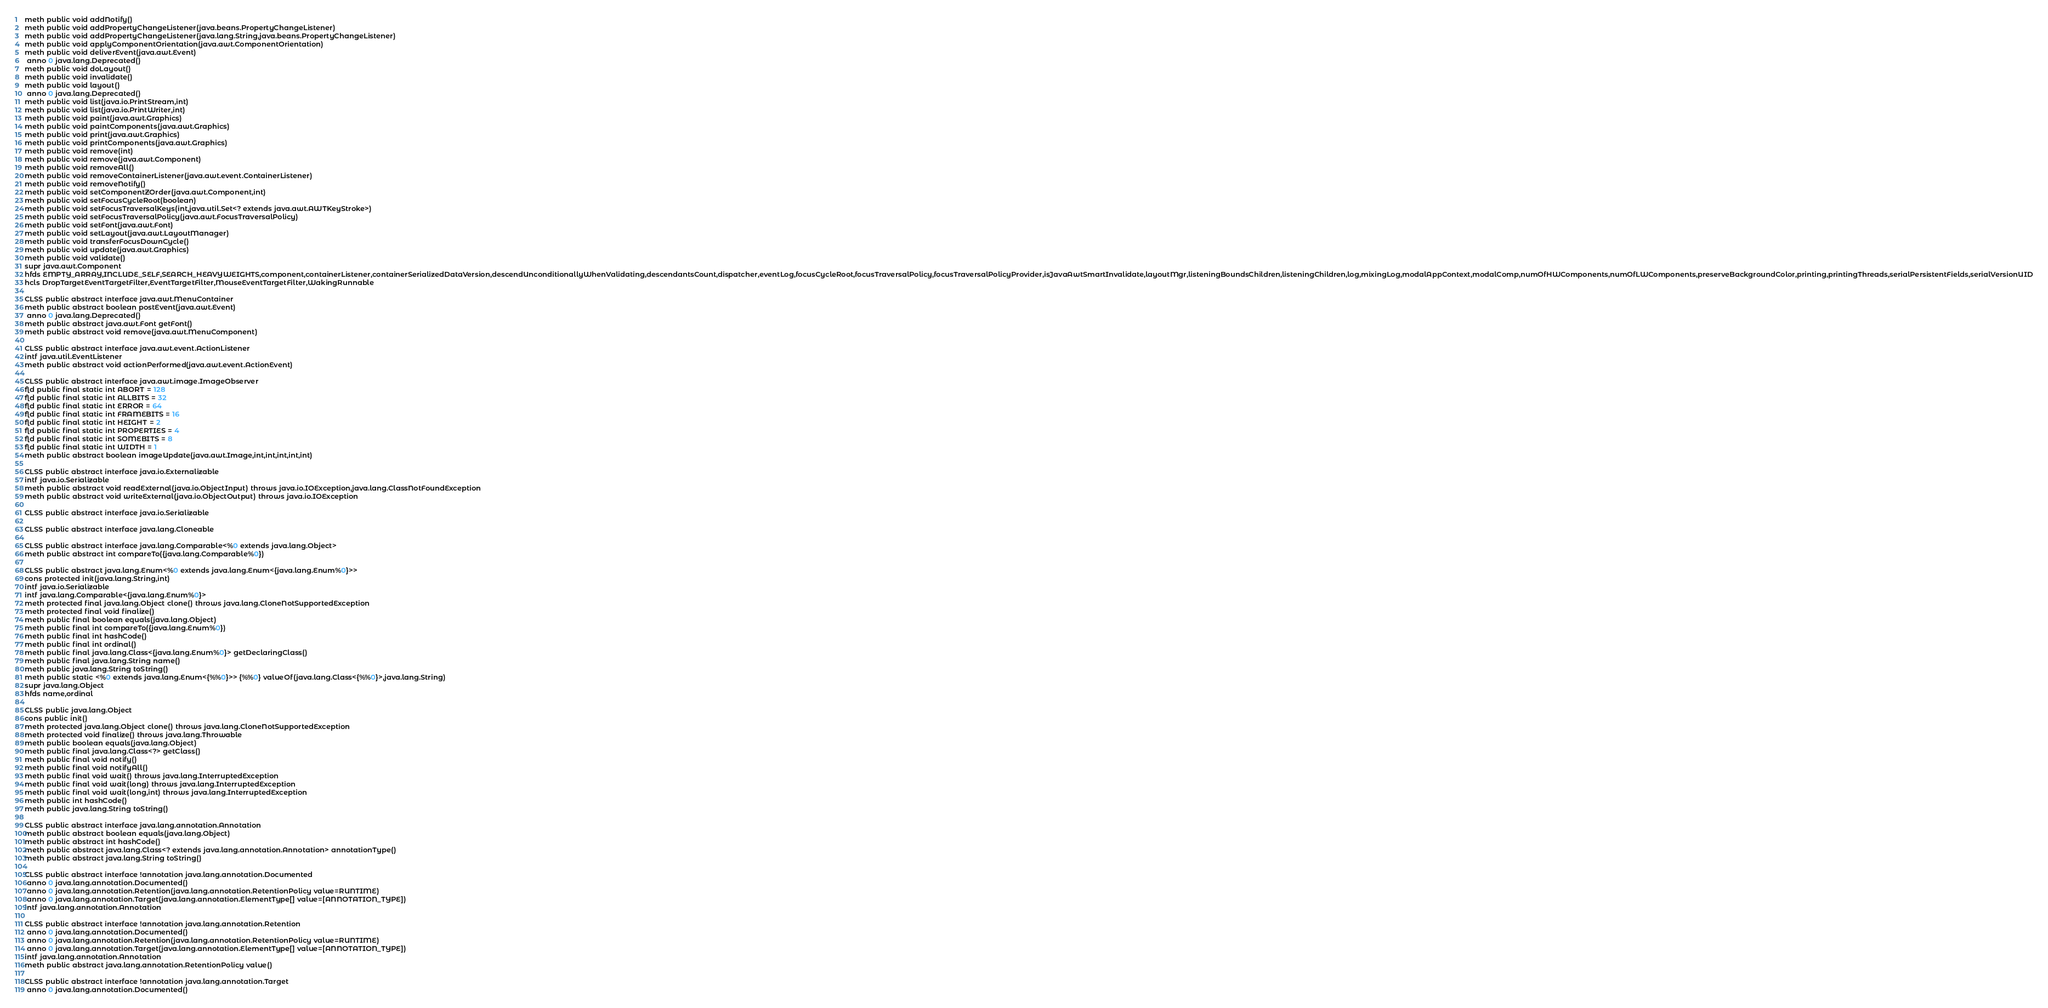Convert code to text. <code><loc_0><loc_0><loc_500><loc_500><_SML_>meth public void addNotify()
meth public void addPropertyChangeListener(java.beans.PropertyChangeListener)
meth public void addPropertyChangeListener(java.lang.String,java.beans.PropertyChangeListener)
meth public void applyComponentOrientation(java.awt.ComponentOrientation)
meth public void deliverEvent(java.awt.Event)
 anno 0 java.lang.Deprecated()
meth public void doLayout()
meth public void invalidate()
meth public void layout()
 anno 0 java.lang.Deprecated()
meth public void list(java.io.PrintStream,int)
meth public void list(java.io.PrintWriter,int)
meth public void paint(java.awt.Graphics)
meth public void paintComponents(java.awt.Graphics)
meth public void print(java.awt.Graphics)
meth public void printComponents(java.awt.Graphics)
meth public void remove(int)
meth public void remove(java.awt.Component)
meth public void removeAll()
meth public void removeContainerListener(java.awt.event.ContainerListener)
meth public void removeNotify()
meth public void setComponentZOrder(java.awt.Component,int)
meth public void setFocusCycleRoot(boolean)
meth public void setFocusTraversalKeys(int,java.util.Set<? extends java.awt.AWTKeyStroke>)
meth public void setFocusTraversalPolicy(java.awt.FocusTraversalPolicy)
meth public void setFont(java.awt.Font)
meth public void setLayout(java.awt.LayoutManager)
meth public void transferFocusDownCycle()
meth public void update(java.awt.Graphics)
meth public void validate()
supr java.awt.Component
hfds EMPTY_ARRAY,INCLUDE_SELF,SEARCH_HEAVYWEIGHTS,component,containerListener,containerSerializedDataVersion,descendUnconditionallyWhenValidating,descendantsCount,dispatcher,eventLog,focusCycleRoot,focusTraversalPolicy,focusTraversalPolicyProvider,isJavaAwtSmartInvalidate,layoutMgr,listeningBoundsChildren,listeningChildren,log,mixingLog,modalAppContext,modalComp,numOfHWComponents,numOfLWComponents,preserveBackgroundColor,printing,printingThreads,serialPersistentFields,serialVersionUID
hcls DropTargetEventTargetFilter,EventTargetFilter,MouseEventTargetFilter,WakingRunnable

CLSS public abstract interface java.awt.MenuContainer
meth public abstract boolean postEvent(java.awt.Event)
 anno 0 java.lang.Deprecated()
meth public abstract java.awt.Font getFont()
meth public abstract void remove(java.awt.MenuComponent)

CLSS public abstract interface java.awt.event.ActionListener
intf java.util.EventListener
meth public abstract void actionPerformed(java.awt.event.ActionEvent)

CLSS public abstract interface java.awt.image.ImageObserver
fld public final static int ABORT = 128
fld public final static int ALLBITS = 32
fld public final static int ERROR = 64
fld public final static int FRAMEBITS = 16
fld public final static int HEIGHT = 2
fld public final static int PROPERTIES = 4
fld public final static int SOMEBITS = 8
fld public final static int WIDTH = 1
meth public abstract boolean imageUpdate(java.awt.Image,int,int,int,int,int)

CLSS public abstract interface java.io.Externalizable
intf java.io.Serializable
meth public abstract void readExternal(java.io.ObjectInput) throws java.io.IOException,java.lang.ClassNotFoundException
meth public abstract void writeExternal(java.io.ObjectOutput) throws java.io.IOException

CLSS public abstract interface java.io.Serializable

CLSS public abstract interface java.lang.Cloneable

CLSS public abstract interface java.lang.Comparable<%0 extends java.lang.Object>
meth public abstract int compareTo({java.lang.Comparable%0})

CLSS public abstract java.lang.Enum<%0 extends java.lang.Enum<{java.lang.Enum%0}>>
cons protected init(java.lang.String,int)
intf java.io.Serializable
intf java.lang.Comparable<{java.lang.Enum%0}>
meth protected final java.lang.Object clone() throws java.lang.CloneNotSupportedException
meth protected final void finalize()
meth public final boolean equals(java.lang.Object)
meth public final int compareTo({java.lang.Enum%0})
meth public final int hashCode()
meth public final int ordinal()
meth public final java.lang.Class<{java.lang.Enum%0}> getDeclaringClass()
meth public final java.lang.String name()
meth public java.lang.String toString()
meth public static <%0 extends java.lang.Enum<{%%0}>> {%%0} valueOf(java.lang.Class<{%%0}>,java.lang.String)
supr java.lang.Object
hfds name,ordinal

CLSS public java.lang.Object
cons public init()
meth protected java.lang.Object clone() throws java.lang.CloneNotSupportedException
meth protected void finalize() throws java.lang.Throwable
meth public boolean equals(java.lang.Object)
meth public final java.lang.Class<?> getClass()
meth public final void notify()
meth public final void notifyAll()
meth public final void wait() throws java.lang.InterruptedException
meth public final void wait(long) throws java.lang.InterruptedException
meth public final void wait(long,int) throws java.lang.InterruptedException
meth public int hashCode()
meth public java.lang.String toString()

CLSS public abstract interface java.lang.annotation.Annotation
meth public abstract boolean equals(java.lang.Object)
meth public abstract int hashCode()
meth public abstract java.lang.Class<? extends java.lang.annotation.Annotation> annotationType()
meth public abstract java.lang.String toString()

CLSS public abstract interface !annotation java.lang.annotation.Documented
 anno 0 java.lang.annotation.Documented()
 anno 0 java.lang.annotation.Retention(java.lang.annotation.RetentionPolicy value=RUNTIME)
 anno 0 java.lang.annotation.Target(java.lang.annotation.ElementType[] value=[ANNOTATION_TYPE])
intf java.lang.annotation.Annotation

CLSS public abstract interface !annotation java.lang.annotation.Retention
 anno 0 java.lang.annotation.Documented()
 anno 0 java.lang.annotation.Retention(java.lang.annotation.RetentionPolicy value=RUNTIME)
 anno 0 java.lang.annotation.Target(java.lang.annotation.ElementType[] value=[ANNOTATION_TYPE])
intf java.lang.annotation.Annotation
meth public abstract java.lang.annotation.RetentionPolicy value()

CLSS public abstract interface !annotation java.lang.annotation.Target
 anno 0 java.lang.annotation.Documented()</code> 